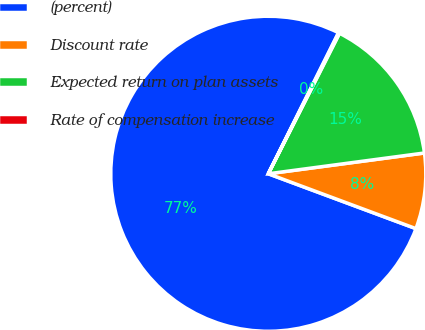<chart> <loc_0><loc_0><loc_500><loc_500><pie_chart><fcel>(percent)<fcel>Discount rate<fcel>Expected return on plan assets<fcel>Rate of compensation increase<nl><fcel>76.7%<fcel>7.77%<fcel>15.43%<fcel>0.11%<nl></chart> 